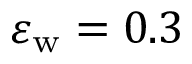<formula> <loc_0><loc_0><loc_500><loc_500>\varepsilon _ { w } = 0 . 3</formula> 